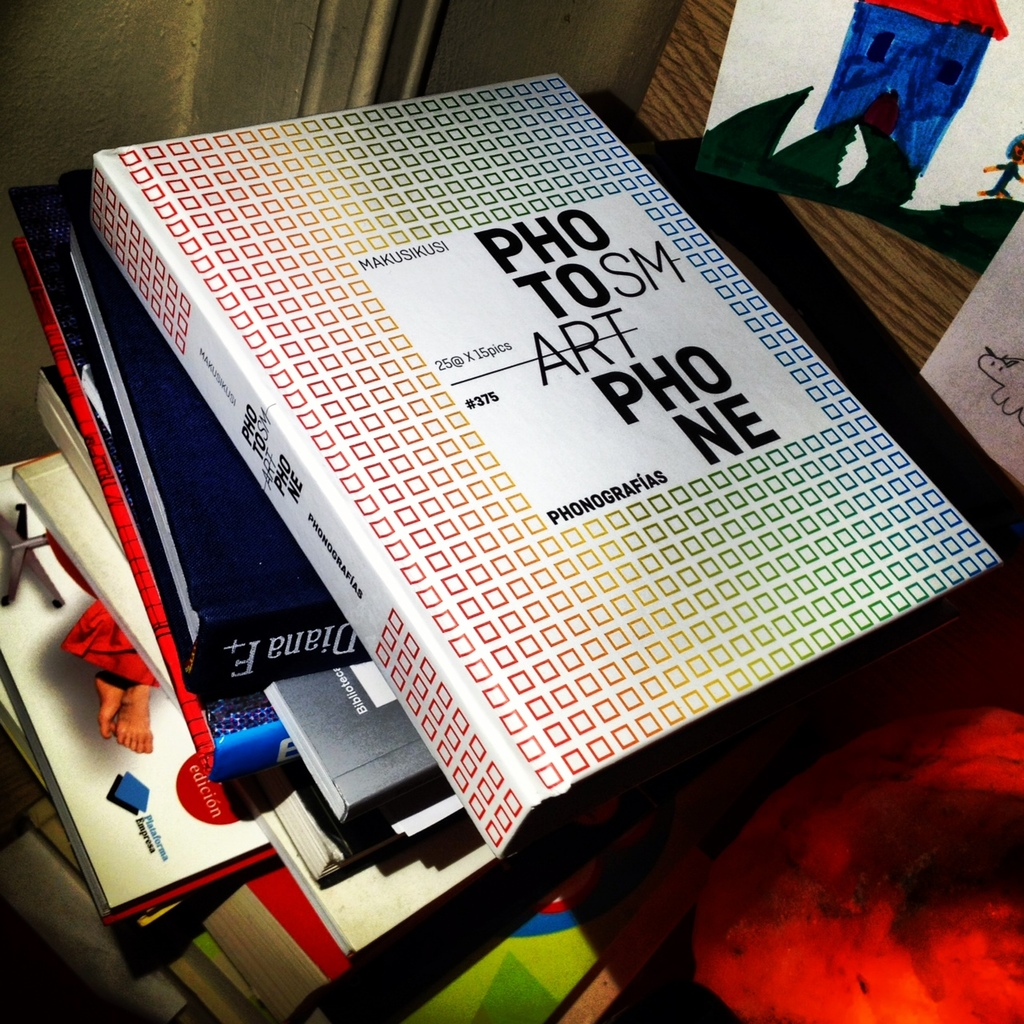Can you describe the other items seen with the book in the image? Alongside the prominently displayed book, there are several other books with varying covers, a red fabric possibly part of a bag or a cover, and what appears to be children’s artwork in the background, adding a personal and artistic layer to the scene. 